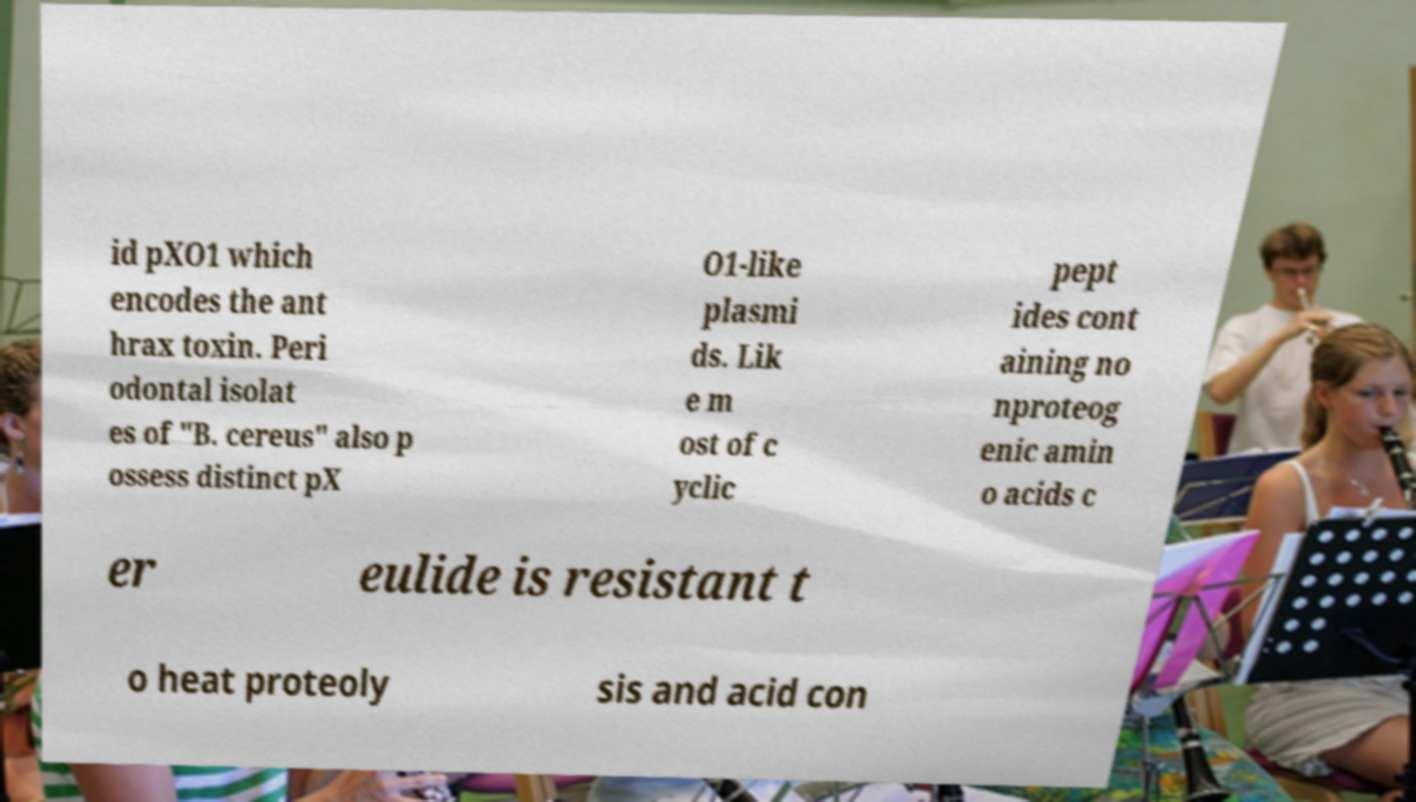Could you extract and type out the text from this image? id pXO1 which encodes the ant hrax toxin. Peri odontal isolat es of "B. cereus" also p ossess distinct pX O1-like plasmi ds. Lik e m ost of c yclic pept ides cont aining no nproteog enic amin o acids c er eulide is resistant t o heat proteoly sis and acid con 